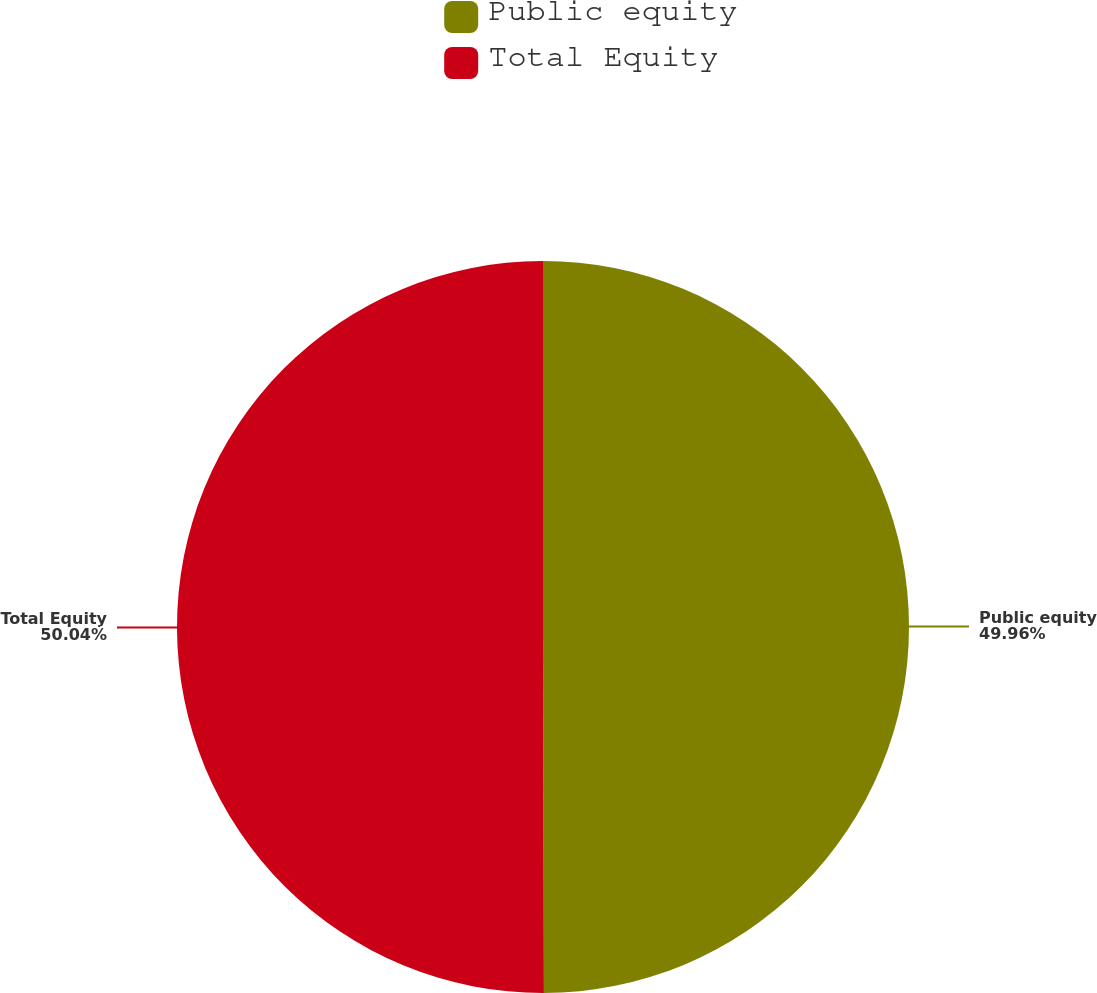Convert chart to OTSL. <chart><loc_0><loc_0><loc_500><loc_500><pie_chart><fcel>Public equity<fcel>Total Equity<nl><fcel>49.96%<fcel>50.04%<nl></chart> 